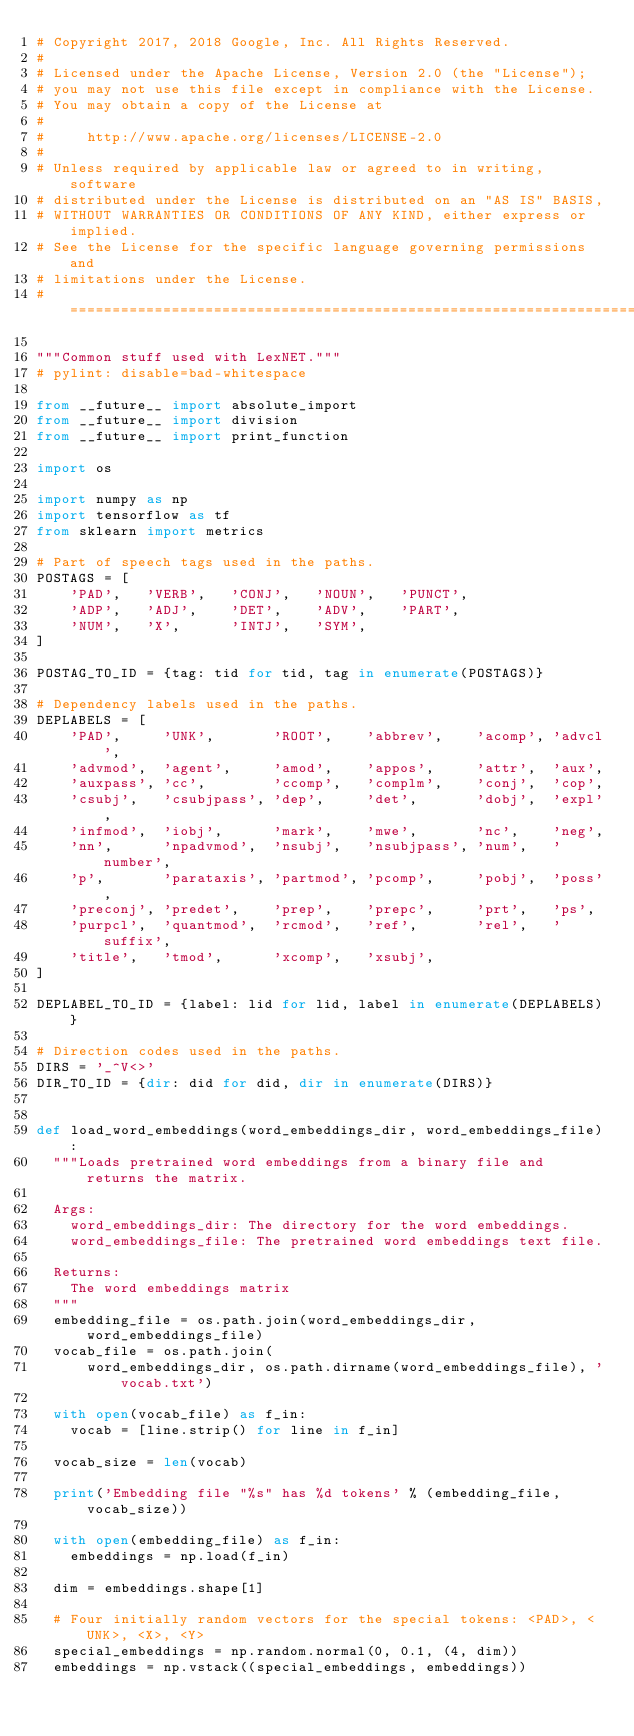Convert code to text. <code><loc_0><loc_0><loc_500><loc_500><_Python_># Copyright 2017, 2018 Google, Inc. All Rights Reserved.
#
# Licensed under the Apache License, Version 2.0 (the "License");
# you may not use this file except in compliance with the License.
# You may obtain a copy of the License at
#
#     http://www.apache.org/licenses/LICENSE-2.0
#
# Unless required by applicable law or agreed to in writing, software
# distributed under the License is distributed on an "AS IS" BASIS,
# WITHOUT WARRANTIES OR CONDITIONS OF ANY KIND, either express or implied.
# See the License for the specific language governing permissions and
# limitations under the License.
# ==============================================================================

"""Common stuff used with LexNET."""
# pylint: disable=bad-whitespace

from __future__ import absolute_import
from __future__ import division
from __future__ import print_function

import os

import numpy as np
import tensorflow as tf
from sklearn import metrics

# Part of speech tags used in the paths.
POSTAGS = [
    'PAD',   'VERB',   'CONJ',   'NOUN',   'PUNCT',
    'ADP',   'ADJ',    'DET',    'ADV',    'PART',
    'NUM',   'X',      'INTJ',   'SYM',
]

POSTAG_TO_ID = {tag: tid for tid, tag in enumerate(POSTAGS)}

# Dependency labels used in the paths.
DEPLABELS = [
    'PAD',     'UNK',       'ROOT',    'abbrev',    'acomp', 'advcl',
    'advmod',  'agent',     'amod',    'appos',     'attr',  'aux',
    'auxpass', 'cc',        'ccomp',   'complm',    'conj',  'cop',
    'csubj',   'csubjpass', 'dep',     'det',       'dobj',  'expl',
    'infmod',  'iobj',      'mark',    'mwe',       'nc',    'neg',
    'nn',      'npadvmod',  'nsubj',   'nsubjpass', 'num',   'number',
    'p',       'parataxis', 'partmod', 'pcomp',     'pobj',  'poss',
    'preconj', 'predet',    'prep',    'prepc',     'prt',   'ps',
    'purpcl',  'quantmod',  'rcmod',   'ref',       'rel',   'suffix',
    'title',   'tmod',      'xcomp',   'xsubj',
]

DEPLABEL_TO_ID = {label: lid for lid, label in enumerate(DEPLABELS)}

# Direction codes used in the paths.
DIRS = '_^V<>'
DIR_TO_ID = {dir: did for did, dir in enumerate(DIRS)}


def load_word_embeddings(word_embeddings_dir, word_embeddings_file):
  """Loads pretrained word embeddings from a binary file and returns the matrix.

  Args:
    word_embeddings_dir: The directory for the word embeddings.
    word_embeddings_file: The pretrained word embeddings text file.

  Returns:
    The word embeddings matrix
  """
  embedding_file = os.path.join(word_embeddings_dir, word_embeddings_file)
  vocab_file = os.path.join(
      word_embeddings_dir, os.path.dirname(word_embeddings_file), 'vocab.txt')

  with open(vocab_file) as f_in:
    vocab = [line.strip() for line in f_in]

  vocab_size = len(vocab)

  print('Embedding file "%s" has %d tokens' % (embedding_file, vocab_size))

  with open(embedding_file) as f_in:
    embeddings = np.load(f_in)

  dim = embeddings.shape[1]

  # Four initially random vectors for the special tokens: <PAD>, <UNK>, <X>, <Y>
  special_embeddings = np.random.normal(0, 0.1, (4, dim))
  embeddings = np.vstack((special_embeddings, embeddings))</code> 